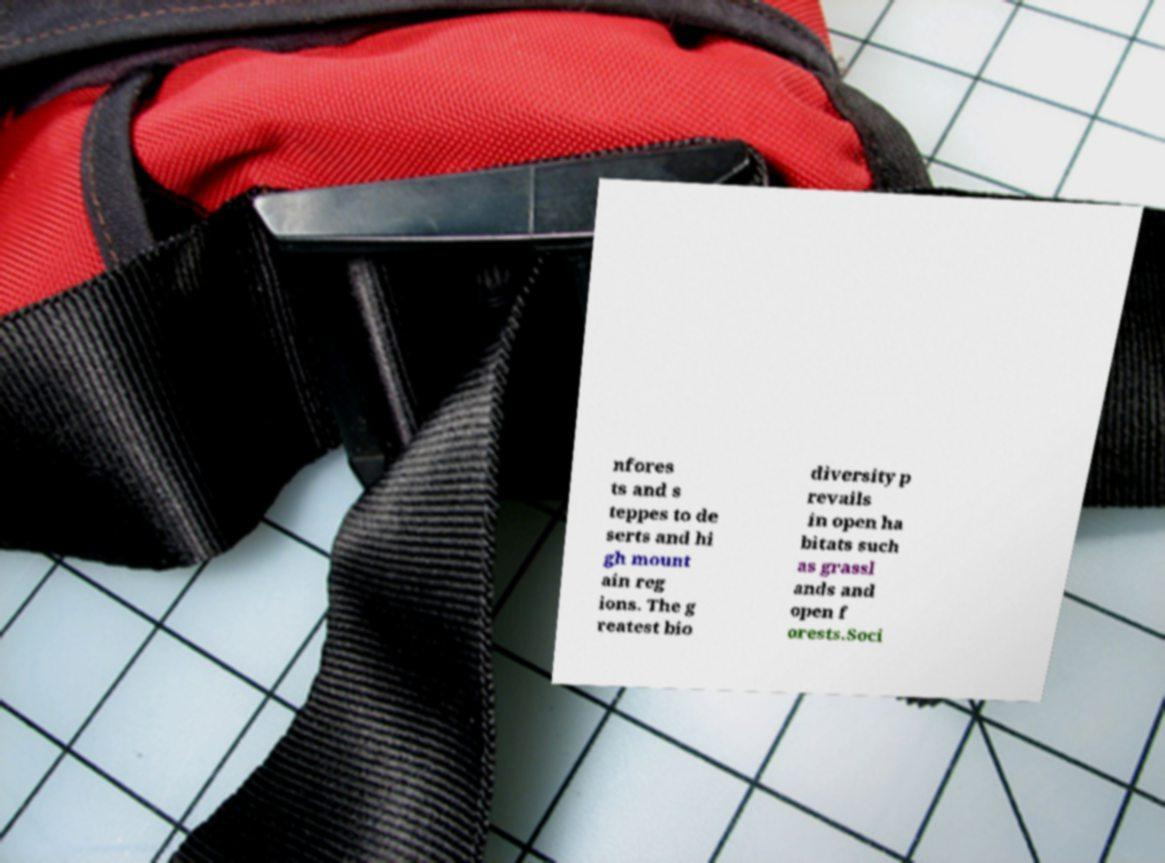What messages or text are displayed in this image? I need them in a readable, typed format. nfores ts and s teppes to de serts and hi gh mount ain reg ions. The g reatest bio diversity p revails in open ha bitats such as grassl ands and open f orests.Soci 